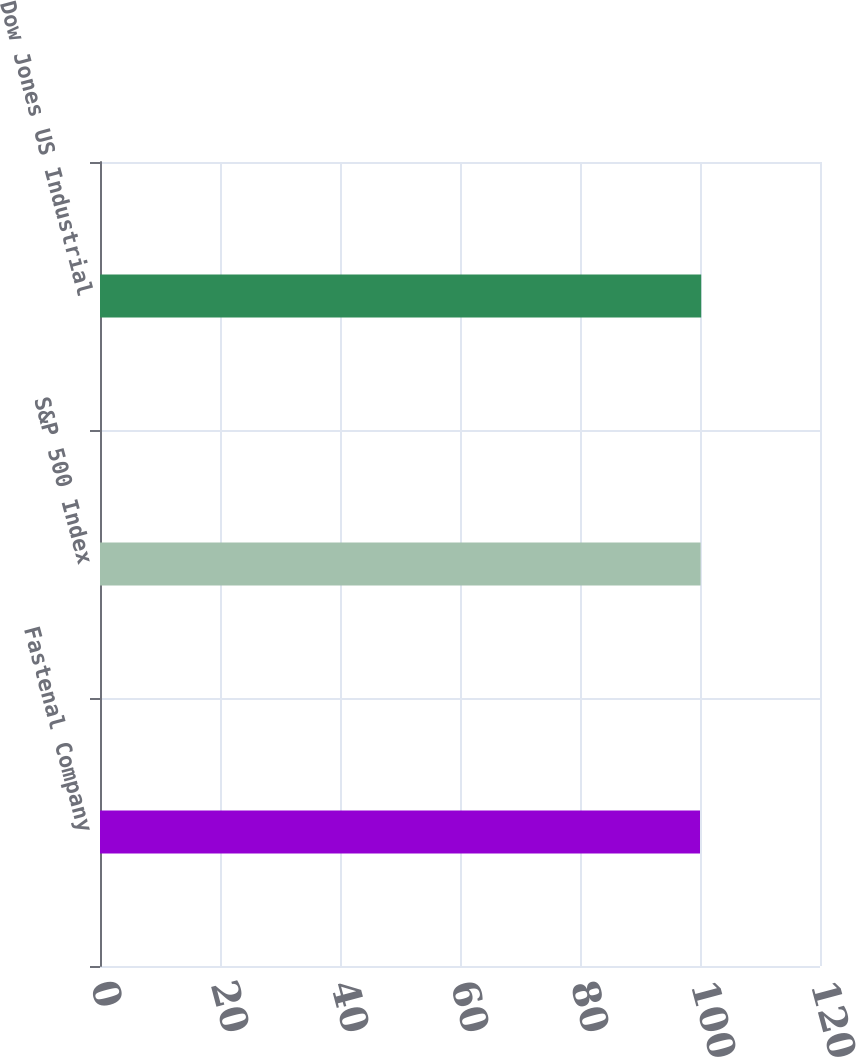Convert chart to OTSL. <chart><loc_0><loc_0><loc_500><loc_500><bar_chart><fcel>Fastenal Company<fcel>S&P 500 Index<fcel>Dow Jones US Industrial<nl><fcel>100<fcel>100.1<fcel>100.2<nl></chart> 